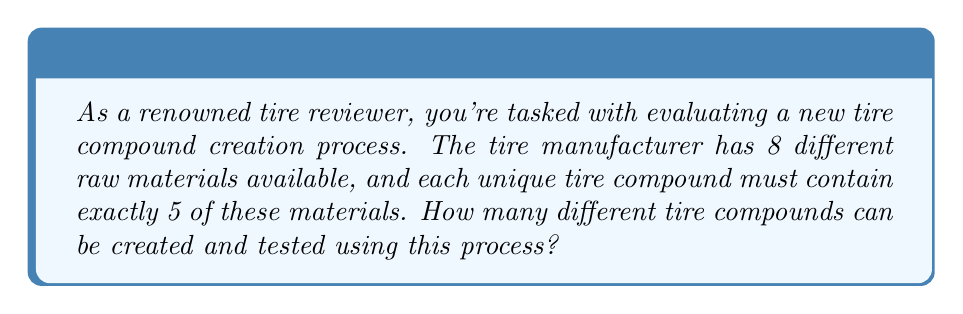Can you solve this math problem? To solve this problem, we need to use the combination formula. Here's why:

1. We are selecting 5 materials out of 8 available materials.
2. The order of selection doesn't matter (e.g., selecting materials A, B, C, D, E is the same as selecting B, A, E, C, D).
3. We can't repeat materials in a single compound.

These conditions match the definition of a combination.

The formula for combinations is:

$$ C(n,r) = \binom{n}{r} = \frac{n!}{r!(n-r)!} $$

Where:
$n$ is the total number of items to choose from (in this case, 8 raw materials)
$r$ is the number of items being chosen (in this case, 5 materials for each compound)

Plugging in our values:

$$ C(8,5) = \binom{8}{5} = \frac{8!}{5!(8-5)!} = \frac{8!}{5!3!} $$

Now let's calculate this step-by-step:

1) $8! = 8 \times 7 \times 6 \times 5 \times 4 \times 3 \times 2 \times 1 = 40,320$
2) $5! = 5 \times 4 \times 3 \times 2 \times 1 = 120$
3) $3! = 3 \times 2 \times 1 = 6$

Substituting these values:

$$ \frac{40,320}{120 \times 6} = \frac{40,320}{720} = 56 $$

Therefore, there are 56 unique tire compounds that can be created and tested.
Answer: 56 unique tire compounds 